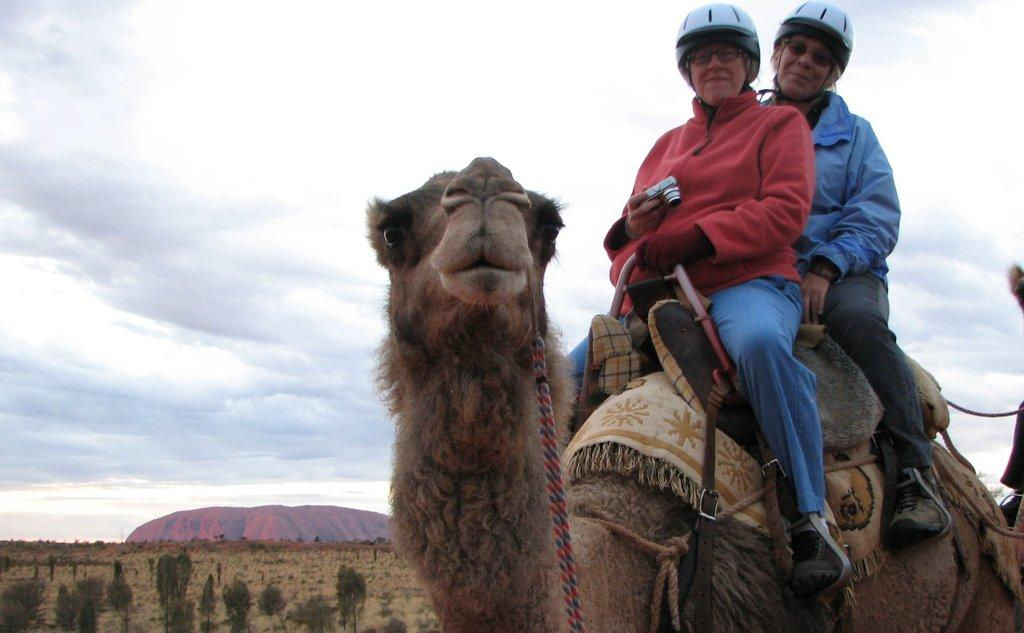How many women are in the image? There are two women in the image. What are the women doing in the image? The women are sitting on a camel. What colors are the sweaters worn by the women? One woman is wearing a red sweater, and the other woman is wearing a blue sweater. What is the condition of the sky in the image? The sky is cloudy in the image. What type of bread can be seen in the image? There is no bread present in the image. How many offices can be seen in the image? There are no offices present in the image. 